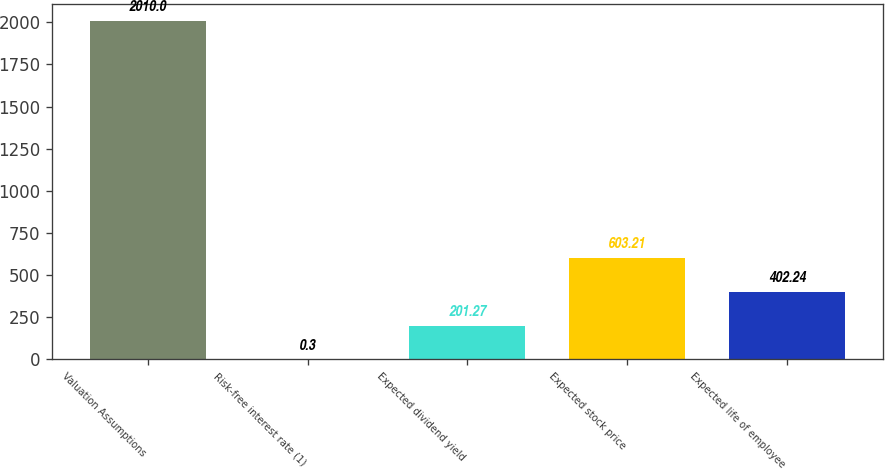Convert chart to OTSL. <chart><loc_0><loc_0><loc_500><loc_500><bar_chart><fcel>Valuation Assumptions<fcel>Risk-free interest rate (1)<fcel>Expected dividend yield<fcel>Expected stock price<fcel>Expected life of employee<nl><fcel>2010<fcel>0.3<fcel>201.27<fcel>603.21<fcel>402.24<nl></chart> 